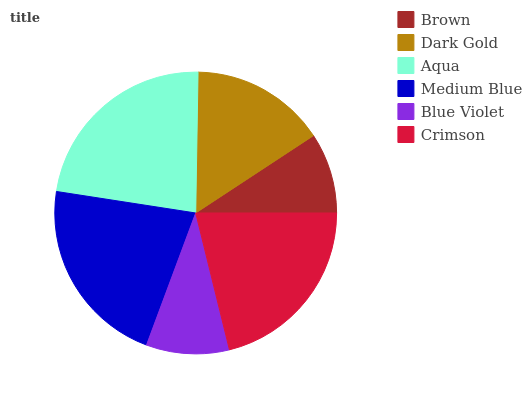Is Brown the minimum?
Answer yes or no. Yes. Is Aqua the maximum?
Answer yes or no. Yes. Is Dark Gold the minimum?
Answer yes or no. No. Is Dark Gold the maximum?
Answer yes or no. No. Is Dark Gold greater than Brown?
Answer yes or no. Yes. Is Brown less than Dark Gold?
Answer yes or no. Yes. Is Brown greater than Dark Gold?
Answer yes or no. No. Is Dark Gold less than Brown?
Answer yes or no. No. Is Crimson the high median?
Answer yes or no. Yes. Is Dark Gold the low median?
Answer yes or no. Yes. Is Dark Gold the high median?
Answer yes or no. No. Is Medium Blue the low median?
Answer yes or no. No. 